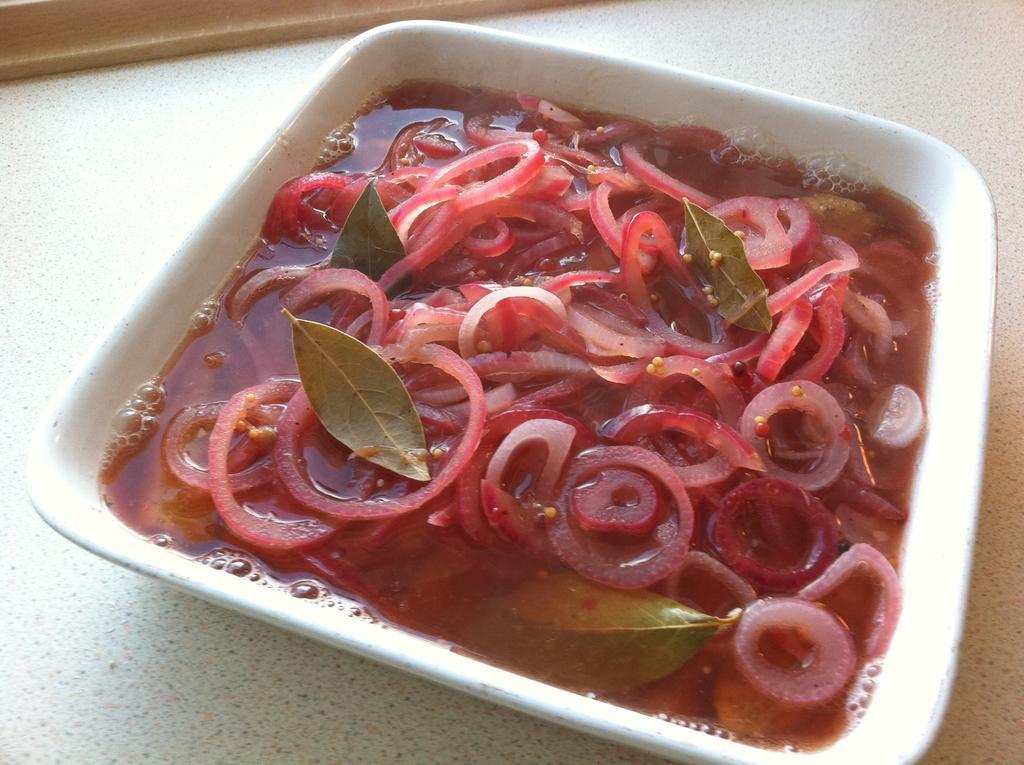Can you describe this image briefly? In this image we can see red onions in the bowl, where are the curry leaves. 